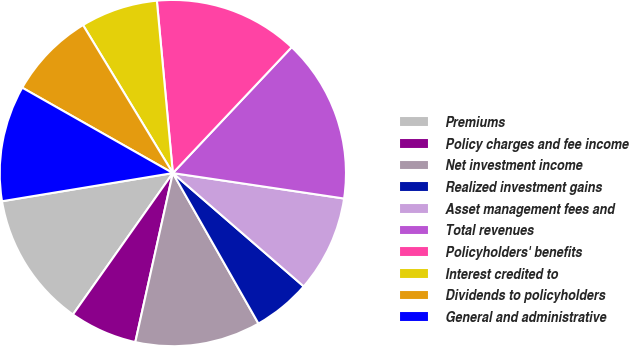<chart> <loc_0><loc_0><loc_500><loc_500><pie_chart><fcel>Premiums<fcel>Policy charges and fee income<fcel>Net investment income<fcel>Realized investment gains<fcel>Asset management fees and<fcel>Total revenues<fcel>Policyholders' benefits<fcel>Interest credited to<fcel>Dividends to policyholders<fcel>General and administrative<nl><fcel>12.61%<fcel>6.31%<fcel>11.71%<fcel>5.41%<fcel>9.01%<fcel>15.31%<fcel>13.51%<fcel>7.21%<fcel>8.11%<fcel>10.81%<nl></chart> 